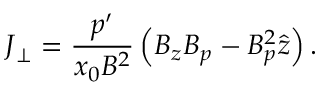Convert formula to latex. <formula><loc_0><loc_0><loc_500><loc_500>J _ { \perp } = \frac { p ^ { \prime } } { x _ { 0 } B ^ { 2 } } \left ( B _ { z } B _ { p } - B _ { p } ^ { 2 } \hat { z } \right ) .</formula> 